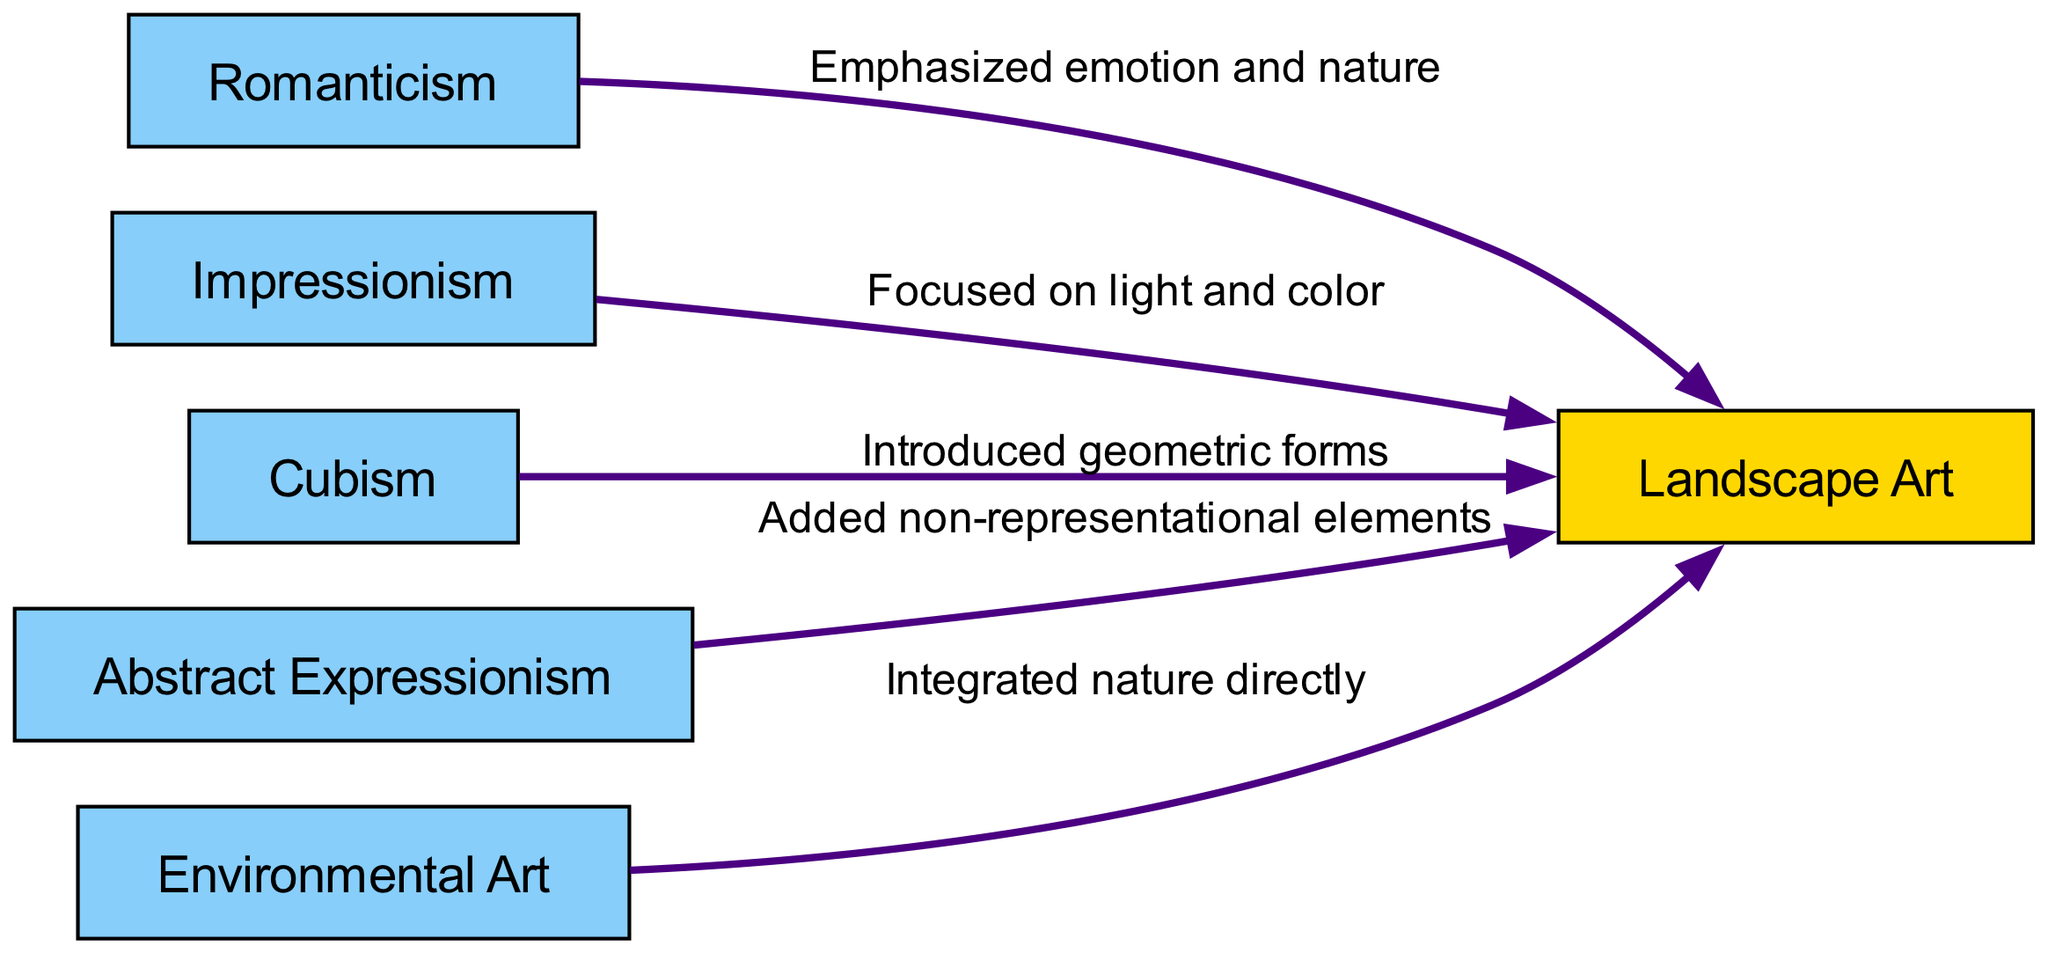What is the total number of nodes in the diagram? The diagram includes six nodes: Landscape Art, Romanticism, Impressionism, Cubism, Abstract Expressionism, and Environmental Art. Counting these gives a total of 6 nodes.
Answer: 6 What kind of relationship does Romanticism have with Landscape Art? The edge between Romanticism and Landscape Art is labeled "Emphasized emotion and nature," indicating that Romanticism influences Landscape Art by highlighting emotional connections to nature.
Answer: Emphasized emotion and nature Which art movement focuses on light and color in landscape art? The edge connecting Impressionism to Landscape Art is labeled "Focused on light and color," showing that Impressionism is the art movement associated with this focus.
Answer: Impressionism How many edges are present in the diagram? There are five edges indicated between the nodes in the diagram: one for each art movement connecting to Landscape Art. Therefore, the total number of edges is 5.
Answer: 5 What influence does Cubism bring to Landscape Art? The relationship between Cubism and Landscape Art is characterized by the label "Introduced geometric forms." This shows that Cubism introduces a specific artistic approach within Landscape Art.
Answer: Introduced geometric forms Which art movement is linked to adding non-representational elements to Landscape Art? The directed edge from Abstract Expressionism to Landscape Art is labeled "Added non-representational elements," indicating that Abstract Expressionism contributes this characteristic.
Answer: Added non-representational elements Which movement directly integrates nature into Landscape Art? The edge from Environmental Art to Landscape Art has the label "Integrated nature directly," illustrating that Environmental Art is specifically focused on this integration.
Answer: Integrated nature directly What is the relationship between Abstract Expressionism and Landscape Art? The interaction shown on the edge leading from Abstract Expressionism to Landscape Art reads "Added non-representational elements," signifying the influence that Abstract Expressionism has within Landscape Art.
Answer: Added non-representational elements Which two movements influence Landscape Art specifically through emotion and nature? Both Romanticism ("Emphasized emotion and nature") and Environmental Art ("Integrated nature directly") influence Landscape Art in distinct ways that relate to emotion and nature. Collectively, they emphasize different aspects of the natural experience.
Answer: Romanticism and Environmental Art 